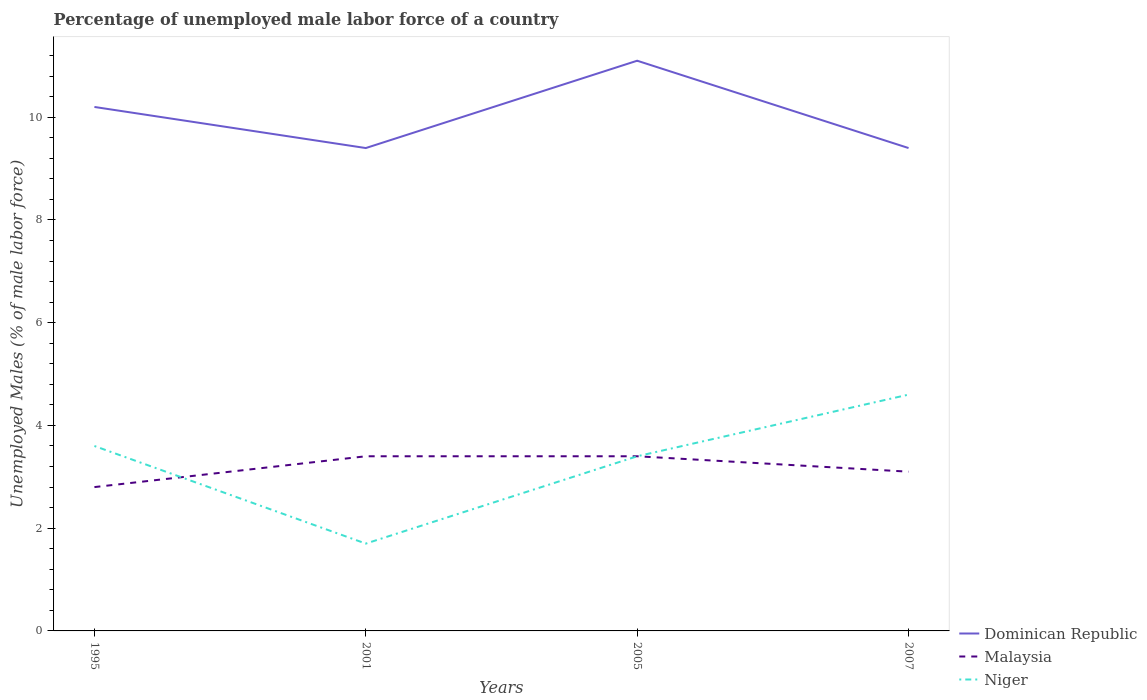Across all years, what is the maximum percentage of unemployed male labor force in Niger?
Your answer should be very brief. 1.7. What is the total percentage of unemployed male labor force in Dominican Republic in the graph?
Your answer should be very brief. 0.8. What is the difference between the highest and the second highest percentage of unemployed male labor force in Niger?
Your answer should be very brief. 2.9. What is the difference between the highest and the lowest percentage of unemployed male labor force in Malaysia?
Your response must be concise. 2. Is the percentage of unemployed male labor force in Dominican Republic strictly greater than the percentage of unemployed male labor force in Niger over the years?
Offer a terse response. No. How many legend labels are there?
Your answer should be very brief. 3. What is the title of the graph?
Offer a terse response. Percentage of unemployed male labor force of a country. What is the label or title of the Y-axis?
Your answer should be compact. Unemployed Males (% of male labor force). What is the Unemployed Males (% of male labor force) of Dominican Republic in 1995?
Give a very brief answer. 10.2. What is the Unemployed Males (% of male labor force) in Malaysia in 1995?
Your answer should be compact. 2.8. What is the Unemployed Males (% of male labor force) in Niger in 1995?
Ensure brevity in your answer.  3.6. What is the Unemployed Males (% of male labor force) of Dominican Republic in 2001?
Make the answer very short. 9.4. What is the Unemployed Males (% of male labor force) in Malaysia in 2001?
Ensure brevity in your answer.  3.4. What is the Unemployed Males (% of male labor force) of Niger in 2001?
Give a very brief answer. 1.7. What is the Unemployed Males (% of male labor force) in Dominican Republic in 2005?
Provide a short and direct response. 11.1. What is the Unemployed Males (% of male labor force) of Malaysia in 2005?
Keep it short and to the point. 3.4. What is the Unemployed Males (% of male labor force) of Niger in 2005?
Offer a terse response. 3.4. What is the Unemployed Males (% of male labor force) in Dominican Republic in 2007?
Provide a succinct answer. 9.4. What is the Unemployed Males (% of male labor force) in Malaysia in 2007?
Offer a terse response. 3.1. What is the Unemployed Males (% of male labor force) in Niger in 2007?
Keep it short and to the point. 4.6. Across all years, what is the maximum Unemployed Males (% of male labor force) of Dominican Republic?
Make the answer very short. 11.1. Across all years, what is the maximum Unemployed Males (% of male labor force) in Malaysia?
Ensure brevity in your answer.  3.4. Across all years, what is the maximum Unemployed Males (% of male labor force) in Niger?
Offer a terse response. 4.6. Across all years, what is the minimum Unemployed Males (% of male labor force) of Dominican Republic?
Your response must be concise. 9.4. Across all years, what is the minimum Unemployed Males (% of male labor force) in Malaysia?
Give a very brief answer. 2.8. Across all years, what is the minimum Unemployed Males (% of male labor force) in Niger?
Give a very brief answer. 1.7. What is the total Unemployed Males (% of male labor force) in Dominican Republic in the graph?
Give a very brief answer. 40.1. What is the total Unemployed Males (% of male labor force) in Niger in the graph?
Offer a very short reply. 13.3. What is the difference between the Unemployed Males (% of male labor force) in Dominican Republic in 1995 and that in 2001?
Provide a short and direct response. 0.8. What is the difference between the Unemployed Males (% of male labor force) in Niger in 1995 and that in 2005?
Give a very brief answer. 0.2. What is the difference between the Unemployed Males (% of male labor force) in Dominican Republic in 1995 and that in 2007?
Give a very brief answer. 0.8. What is the difference between the Unemployed Males (% of male labor force) in Malaysia in 1995 and that in 2007?
Keep it short and to the point. -0.3. What is the difference between the Unemployed Males (% of male labor force) in Malaysia in 2001 and that in 2005?
Offer a terse response. 0. What is the difference between the Unemployed Males (% of male labor force) of Dominican Republic in 2005 and that in 2007?
Offer a very short reply. 1.7. What is the difference between the Unemployed Males (% of male labor force) in Malaysia in 2005 and that in 2007?
Offer a terse response. 0.3. What is the difference between the Unemployed Males (% of male labor force) of Niger in 2005 and that in 2007?
Make the answer very short. -1.2. What is the difference between the Unemployed Males (% of male labor force) of Malaysia in 1995 and the Unemployed Males (% of male labor force) of Niger in 2001?
Offer a terse response. 1.1. What is the difference between the Unemployed Males (% of male labor force) of Dominican Republic in 1995 and the Unemployed Males (% of male labor force) of Malaysia in 2005?
Your answer should be very brief. 6.8. What is the difference between the Unemployed Males (% of male labor force) of Malaysia in 1995 and the Unemployed Males (% of male labor force) of Niger in 2005?
Provide a short and direct response. -0.6. What is the difference between the Unemployed Males (% of male labor force) in Dominican Republic in 1995 and the Unemployed Males (% of male labor force) in Malaysia in 2007?
Keep it short and to the point. 7.1. What is the difference between the Unemployed Males (% of male labor force) of Dominican Republic in 1995 and the Unemployed Males (% of male labor force) of Niger in 2007?
Your answer should be very brief. 5.6. What is the difference between the Unemployed Males (% of male labor force) in Malaysia in 1995 and the Unemployed Males (% of male labor force) in Niger in 2007?
Ensure brevity in your answer.  -1.8. What is the difference between the Unemployed Males (% of male labor force) in Malaysia in 2001 and the Unemployed Males (% of male labor force) in Niger in 2005?
Make the answer very short. 0. What is the difference between the Unemployed Males (% of male labor force) of Dominican Republic in 2001 and the Unemployed Males (% of male labor force) of Niger in 2007?
Provide a short and direct response. 4.8. What is the difference between the Unemployed Males (% of male labor force) in Malaysia in 2001 and the Unemployed Males (% of male labor force) in Niger in 2007?
Provide a short and direct response. -1.2. What is the difference between the Unemployed Males (% of male labor force) of Dominican Republic in 2005 and the Unemployed Males (% of male labor force) of Malaysia in 2007?
Keep it short and to the point. 8. What is the difference between the Unemployed Males (% of male labor force) of Dominican Republic in 2005 and the Unemployed Males (% of male labor force) of Niger in 2007?
Your answer should be compact. 6.5. What is the average Unemployed Males (% of male labor force) of Dominican Republic per year?
Provide a short and direct response. 10.03. What is the average Unemployed Males (% of male labor force) in Malaysia per year?
Provide a succinct answer. 3.17. What is the average Unemployed Males (% of male labor force) of Niger per year?
Give a very brief answer. 3.33. In the year 1995, what is the difference between the Unemployed Males (% of male labor force) in Dominican Republic and Unemployed Males (% of male labor force) in Niger?
Provide a succinct answer. 6.6. In the year 2001, what is the difference between the Unemployed Males (% of male labor force) of Dominican Republic and Unemployed Males (% of male labor force) of Niger?
Offer a terse response. 7.7. In the year 2001, what is the difference between the Unemployed Males (% of male labor force) in Malaysia and Unemployed Males (% of male labor force) in Niger?
Provide a short and direct response. 1.7. In the year 2005, what is the difference between the Unemployed Males (% of male labor force) of Dominican Republic and Unemployed Males (% of male labor force) of Malaysia?
Provide a short and direct response. 7.7. In the year 2005, what is the difference between the Unemployed Males (% of male labor force) of Malaysia and Unemployed Males (% of male labor force) of Niger?
Offer a very short reply. 0. In the year 2007, what is the difference between the Unemployed Males (% of male labor force) in Malaysia and Unemployed Males (% of male labor force) in Niger?
Ensure brevity in your answer.  -1.5. What is the ratio of the Unemployed Males (% of male labor force) in Dominican Republic in 1995 to that in 2001?
Your response must be concise. 1.09. What is the ratio of the Unemployed Males (% of male labor force) of Malaysia in 1995 to that in 2001?
Give a very brief answer. 0.82. What is the ratio of the Unemployed Males (% of male labor force) of Niger in 1995 to that in 2001?
Provide a succinct answer. 2.12. What is the ratio of the Unemployed Males (% of male labor force) in Dominican Republic in 1995 to that in 2005?
Your answer should be compact. 0.92. What is the ratio of the Unemployed Males (% of male labor force) in Malaysia in 1995 to that in 2005?
Offer a very short reply. 0.82. What is the ratio of the Unemployed Males (% of male labor force) of Niger in 1995 to that in 2005?
Your response must be concise. 1.06. What is the ratio of the Unemployed Males (% of male labor force) of Dominican Republic in 1995 to that in 2007?
Offer a very short reply. 1.09. What is the ratio of the Unemployed Males (% of male labor force) of Malaysia in 1995 to that in 2007?
Your answer should be compact. 0.9. What is the ratio of the Unemployed Males (% of male labor force) in Niger in 1995 to that in 2007?
Offer a very short reply. 0.78. What is the ratio of the Unemployed Males (% of male labor force) in Dominican Republic in 2001 to that in 2005?
Your answer should be very brief. 0.85. What is the ratio of the Unemployed Males (% of male labor force) of Dominican Republic in 2001 to that in 2007?
Your answer should be very brief. 1. What is the ratio of the Unemployed Males (% of male labor force) of Malaysia in 2001 to that in 2007?
Offer a very short reply. 1.1. What is the ratio of the Unemployed Males (% of male labor force) in Niger in 2001 to that in 2007?
Provide a succinct answer. 0.37. What is the ratio of the Unemployed Males (% of male labor force) in Dominican Republic in 2005 to that in 2007?
Provide a succinct answer. 1.18. What is the ratio of the Unemployed Males (% of male labor force) of Malaysia in 2005 to that in 2007?
Your answer should be very brief. 1.1. What is the ratio of the Unemployed Males (% of male labor force) in Niger in 2005 to that in 2007?
Your response must be concise. 0.74. What is the difference between the highest and the second highest Unemployed Males (% of male labor force) of Malaysia?
Provide a succinct answer. 0. What is the difference between the highest and the lowest Unemployed Males (% of male labor force) of Dominican Republic?
Your answer should be very brief. 1.7. What is the difference between the highest and the lowest Unemployed Males (% of male labor force) in Niger?
Give a very brief answer. 2.9. 